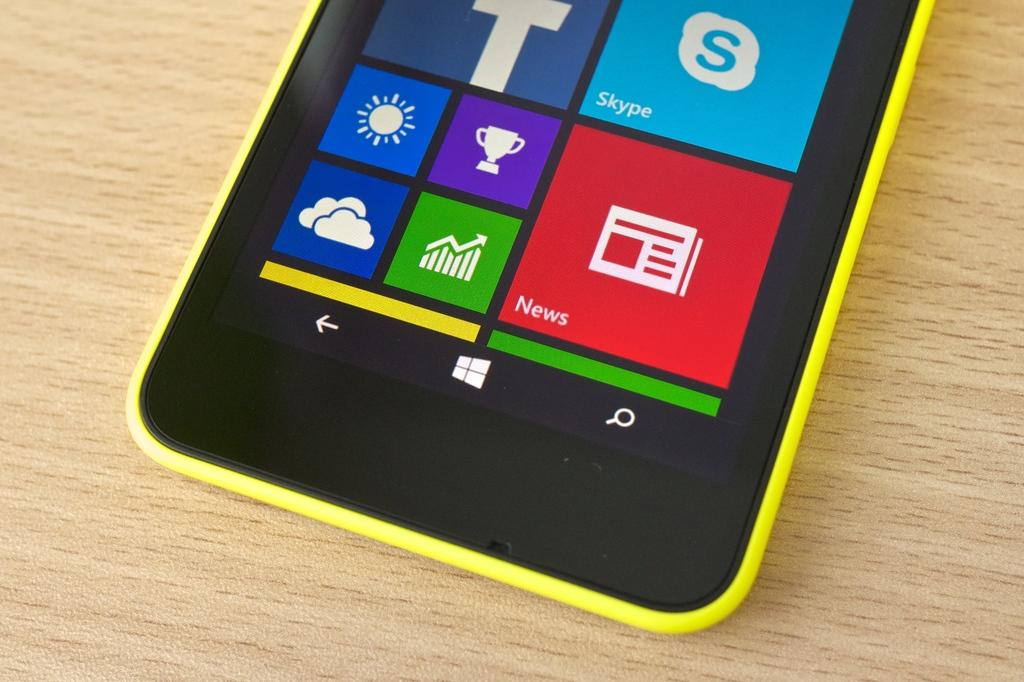<image>
Describe the image concisely. The bottom half of a smartphone with a large red News icon. 